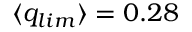<formula> <loc_0><loc_0><loc_500><loc_500>\langle q _ { l i m } \rangle = 0 . 2 8</formula> 